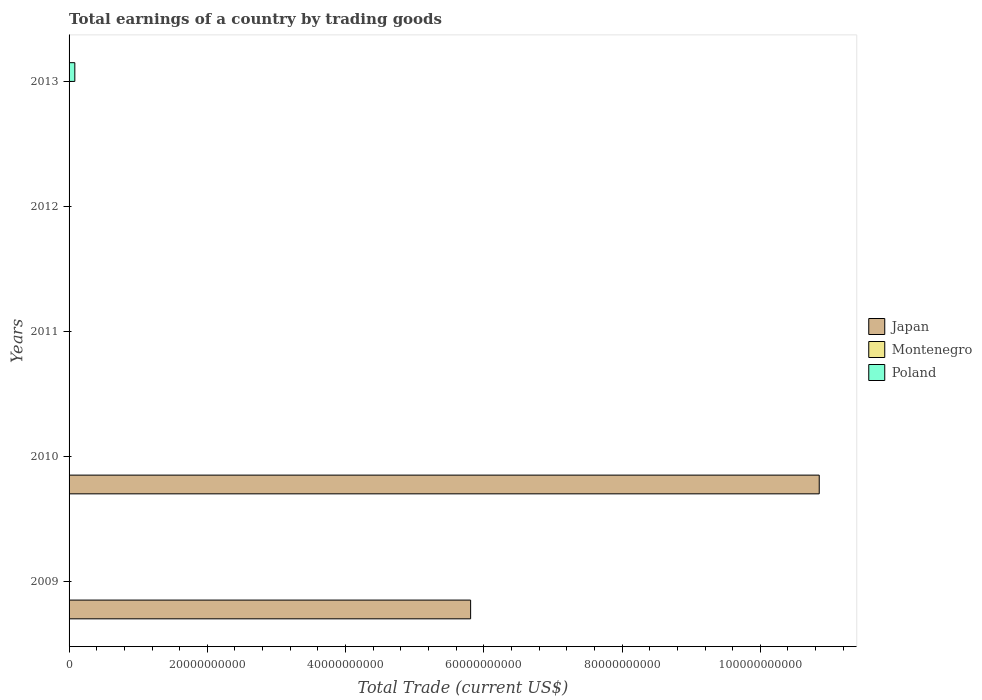Are the number of bars on each tick of the Y-axis equal?
Provide a short and direct response. No. How many bars are there on the 3rd tick from the top?
Provide a succinct answer. 0. What is the label of the 2nd group of bars from the top?
Ensure brevity in your answer.  2012. In how many cases, is the number of bars for a given year not equal to the number of legend labels?
Keep it short and to the point. 5. What is the total earnings in Montenegro in 2009?
Provide a short and direct response. 0. Across all years, what is the maximum total earnings in Poland?
Provide a succinct answer. 8.33e+08. What is the total total earnings in Japan in the graph?
Keep it short and to the point. 1.67e+11. What is the difference between the total earnings in Japan in 2009 and that in 2010?
Your answer should be very brief. -5.04e+1. What is the difference between the total earnings in Japan in 2010 and the total earnings in Poland in 2012?
Your answer should be compact. 1.09e+11. What is the average total earnings in Japan per year?
Give a very brief answer. 3.33e+1. What is the difference between the highest and the lowest total earnings in Poland?
Make the answer very short. 8.33e+08. Are all the bars in the graph horizontal?
Your response must be concise. Yes. How many years are there in the graph?
Your response must be concise. 5. Are the values on the major ticks of X-axis written in scientific E-notation?
Your response must be concise. No. Where does the legend appear in the graph?
Your answer should be very brief. Center right. How many legend labels are there?
Your response must be concise. 3. How are the legend labels stacked?
Your answer should be compact. Vertical. What is the title of the graph?
Provide a short and direct response. Total earnings of a country by trading goods. What is the label or title of the X-axis?
Your answer should be very brief. Total Trade (current US$). What is the label or title of the Y-axis?
Your answer should be compact. Years. What is the Total Trade (current US$) of Japan in 2009?
Give a very brief answer. 5.81e+1. What is the Total Trade (current US$) of Japan in 2010?
Offer a terse response. 1.09e+11. What is the Total Trade (current US$) of Montenegro in 2010?
Your answer should be compact. 0. What is the Total Trade (current US$) of Poland in 2010?
Your answer should be compact. 0. What is the Total Trade (current US$) in Montenegro in 2011?
Your answer should be compact. 0. What is the Total Trade (current US$) of Japan in 2012?
Your answer should be compact. 0. What is the Total Trade (current US$) of Montenegro in 2012?
Ensure brevity in your answer.  0. What is the Total Trade (current US$) in Japan in 2013?
Give a very brief answer. 0. What is the Total Trade (current US$) of Montenegro in 2013?
Keep it short and to the point. 0. What is the Total Trade (current US$) of Poland in 2013?
Make the answer very short. 8.33e+08. Across all years, what is the maximum Total Trade (current US$) of Japan?
Provide a succinct answer. 1.09e+11. Across all years, what is the maximum Total Trade (current US$) of Poland?
Offer a very short reply. 8.33e+08. What is the total Total Trade (current US$) in Japan in the graph?
Your response must be concise. 1.67e+11. What is the total Total Trade (current US$) in Montenegro in the graph?
Provide a short and direct response. 0. What is the total Total Trade (current US$) in Poland in the graph?
Offer a terse response. 8.33e+08. What is the difference between the Total Trade (current US$) of Japan in 2009 and that in 2010?
Ensure brevity in your answer.  -5.04e+1. What is the difference between the Total Trade (current US$) in Japan in 2009 and the Total Trade (current US$) in Poland in 2013?
Make the answer very short. 5.73e+1. What is the difference between the Total Trade (current US$) in Japan in 2010 and the Total Trade (current US$) in Poland in 2013?
Your answer should be very brief. 1.08e+11. What is the average Total Trade (current US$) in Japan per year?
Your response must be concise. 3.33e+1. What is the average Total Trade (current US$) of Poland per year?
Make the answer very short. 1.67e+08. What is the ratio of the Total Trade (current US$) of Japan in 2009 to that in 2010?
Make the answer very short. 0.54. What is the difference between the highest and the lowest Total Trade (current US$) in Japan?
Give a very brief answer. 1.09e+11. What is the difference between the highest and the lowest Total Trade (current US$) in Poland?
Provide a succinct answer. 8.33e+08. 